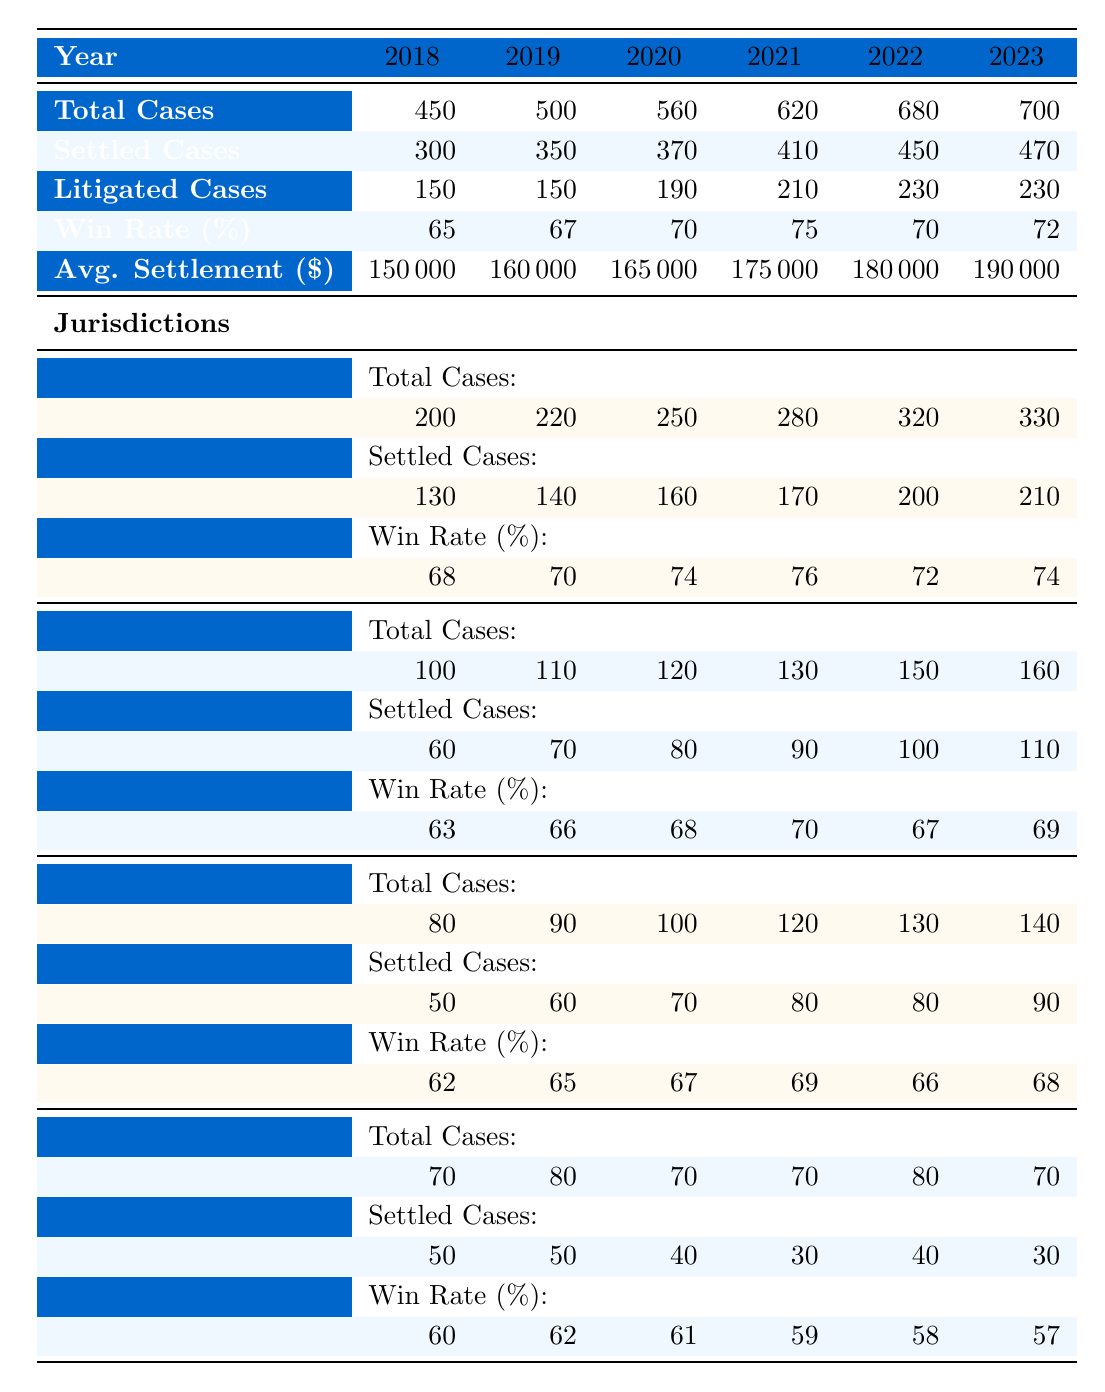What was the win rate for construction defect cases in 2021? The win rate for 2021 is clearly listed in the table under the main row titled "Win Rate (%)," which shows 75% for that year.
Answer: 75% How many total cases were settled in 2022? The total number of settled cases in 2022 can be found in the row labeled "Settled Cases" for that year, which shows a total of 450 cases.
Answer: 450 What is the average settlement amount for all years combined? To find the average settlement amount, sum the values for each year (150000 + 160000 + 165000 + 175000 + 180000 + 190000 = 1025000) and divide by the number of years (6). Thus, 1025000 / 6 = 170833.33, rounded to 170833.
Answer: 170833 In which year did Texas have the highest win rate, and what was that rate? Looking at the win rates for Texas from all years, the highest rate is in 2021, with a win rate of 70%.
Answer: 2021, 70% What was the total number of litigated cases across all years? The total number of litigated cases can be calculated by summing each year's litigated cases (150 + 150 + 190 + 210 + 230 + 230 = 1160).
Answer: 1160 Did Florida have more settled cases than Texas in 2020? In 2020, Florida had 70 settled cases while Texas had 80 settled cases. Since 70 is not more than 80, the answer is no.
Answer: No Which jurisdiction had the highest average settlement amount in 2023? To determine this, we compare the settlement amounts for each jurisdiction in 2023. California has 210000, Texas 110000, Florida 90000, and New York 30000. California has the highest amount.
Answer: California What is the percentage increase in total cases from 2018 to 2023? The total cases in 2018 were 450 and in 2023 were 700. The increase is 700 - 450 = 250. The percentage increase is (250 / 450) * 100 = 55.56%.
Answer: 55.56% How many cases were settled in California in 2021? From the row for California, the value for settled cases in 2021 is 170.
Answer: 170 What is the difference in the number of litigated cases between 2020 and 2022? The number of litigated cases in 2020 is 190, and in 2022 it is 230. The difference is 230 - 190 = 40.
Answer: 40 